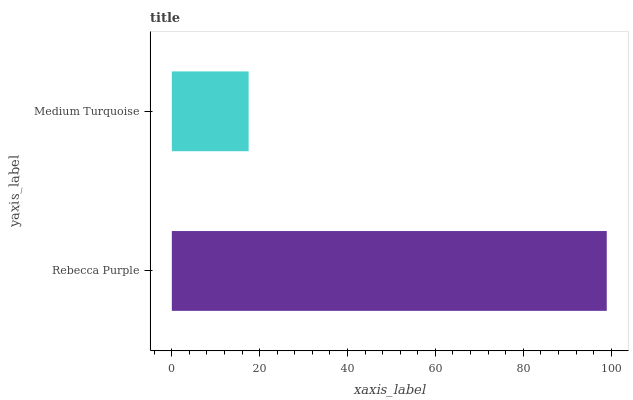Is Medium Turquoise the minimum?
Answer yes or no. Yes. Is Rebecca Purple the maximum?
Answer yes or no. Yes. Is Medium Turquoise the maximum?
Answer yes or no. No. Is Rebecca Purple greater than Medium Turquoise?
Answer yes or no. Yes. Is Medium Turquoise less than Rebecca Purple?
Answer yes or no. Yes. Is Medium Turquoise greater than Rebecca Purple?
Answer yes or no. No. Is Rebecca Purple less than Medium Turquoise?
Answer yes or no. No. Is Rebecca Purple the high median?
Answer yes or no. Yes. Is Medium Turquoise the low median?
Answer yes or no. Yes. Is Medium Turquoise the high median?
Answer yes or no. No. Is Rebecca Purple the low median?
Answer yes or no. No. 